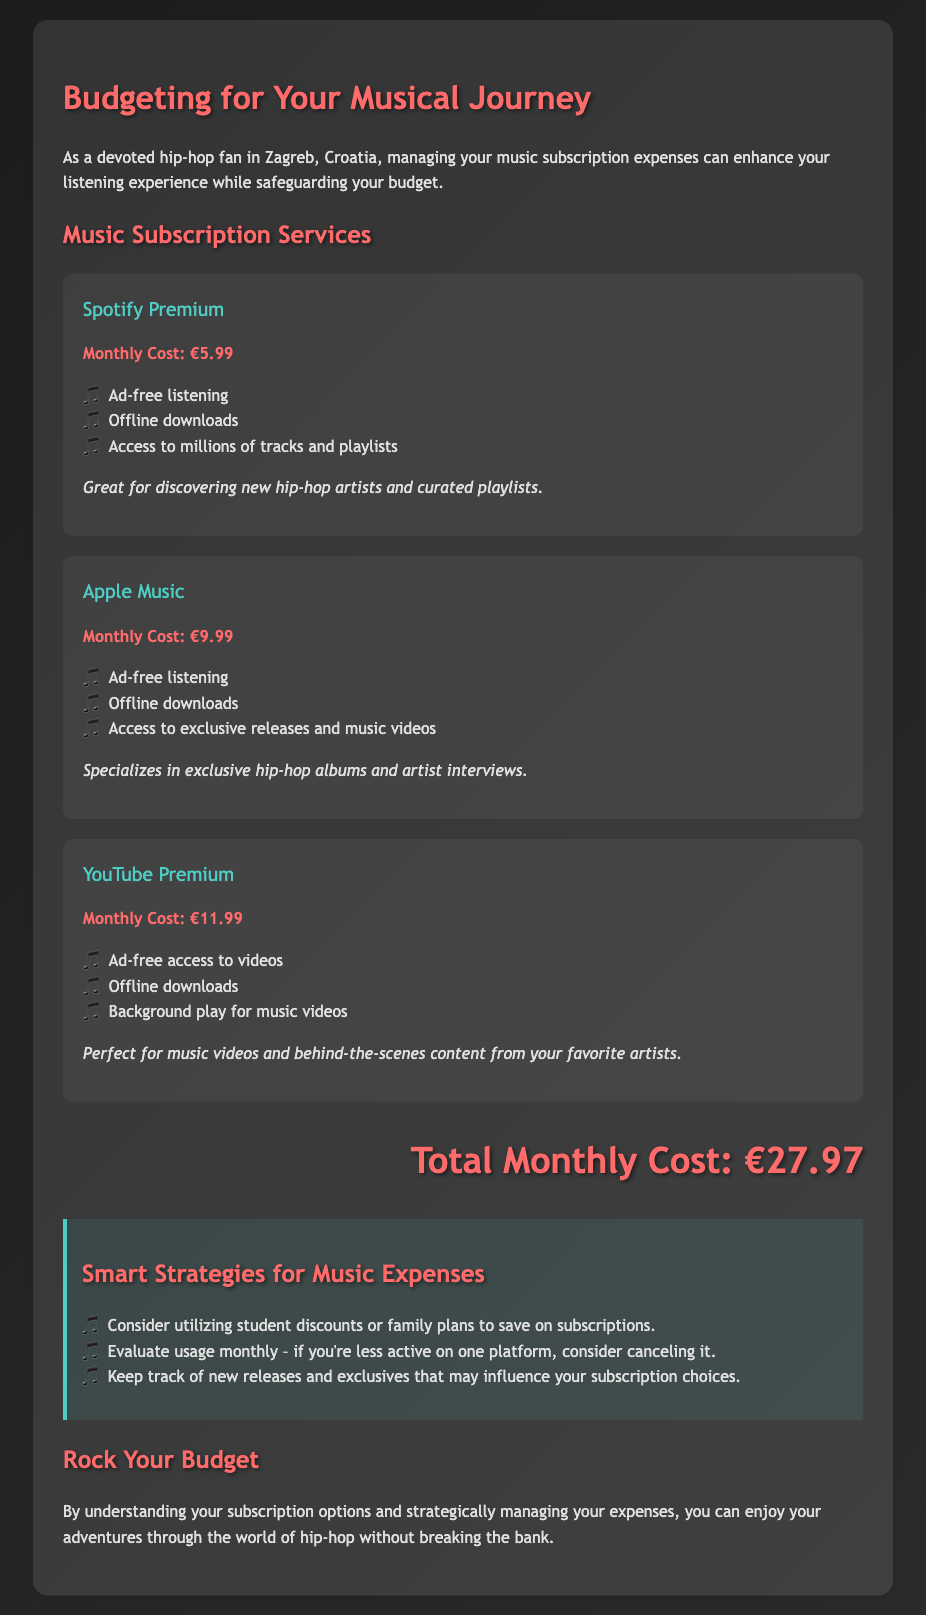What is the monthly cost of Spotify Premium? The monthly cost of Spotify Premium is clearly listed in the document.
Answer: €5.99 What are the three features of Apple Music? The document lists specific features of Apple Music which help in understanding its offerings.
Answer: Ad-free listening, Offline downloads, Access to exclusive releases and music videos What is the total monthly cost for all subscriptions? The total monthly cost is explicitly stated at the end of the document as a summation of all subscription costs.
Answer: €27.97 Which service specializes in exclusive hip-hop albums? The document mentions specific services that cater to hip-hop fans, pointing to a particular one known for exclusives.
Answer: Apple Music What is a suggested strategy for music expenses? The tips section in the document provides strategies for better financial management regarding music subscriptions.
Answer: Utilize student discounts or family plans How much does YouTube Premium cost monthly? The document specifies the monthly cost for each subscription service, including YouTube Premium.
Answer: €11.99 What does the document emphasize for hip-hop fans? The document clearly communicates a theme aimed at hip-hop fans regarding subscription benefits.
Answer: Enjoying adventures through the world of hip-hop What platform provides background play for music videos? The features of music services are included in the document, detailing specific functionalities like background play.
Answer: YouTube Premium 